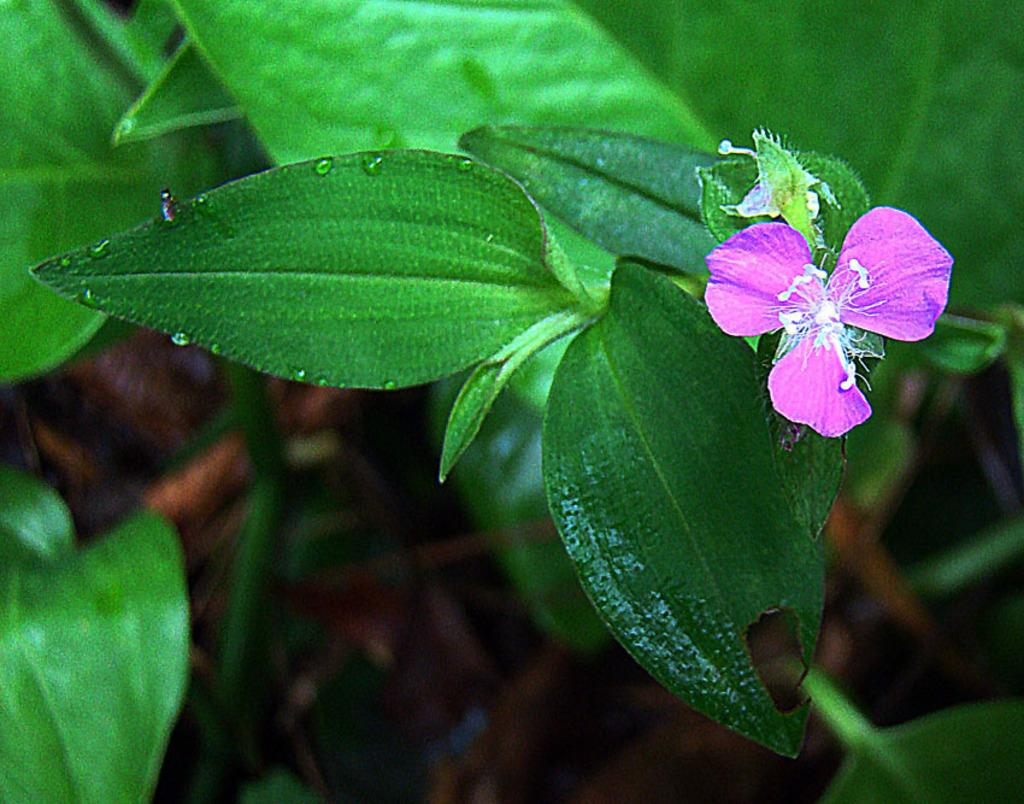What is the main subject of the image? There is a flower in the image. What else can be seen in the image besides the flower? There are leaves visible in the image. Can you describe the background of the image? The background of the image includes branches and leaves, as well as other objects. What type of bulb is used to light up the history of knowledge in the image? There is no bulb, history, or knowledge present in the image; it features a flower and leaves. 